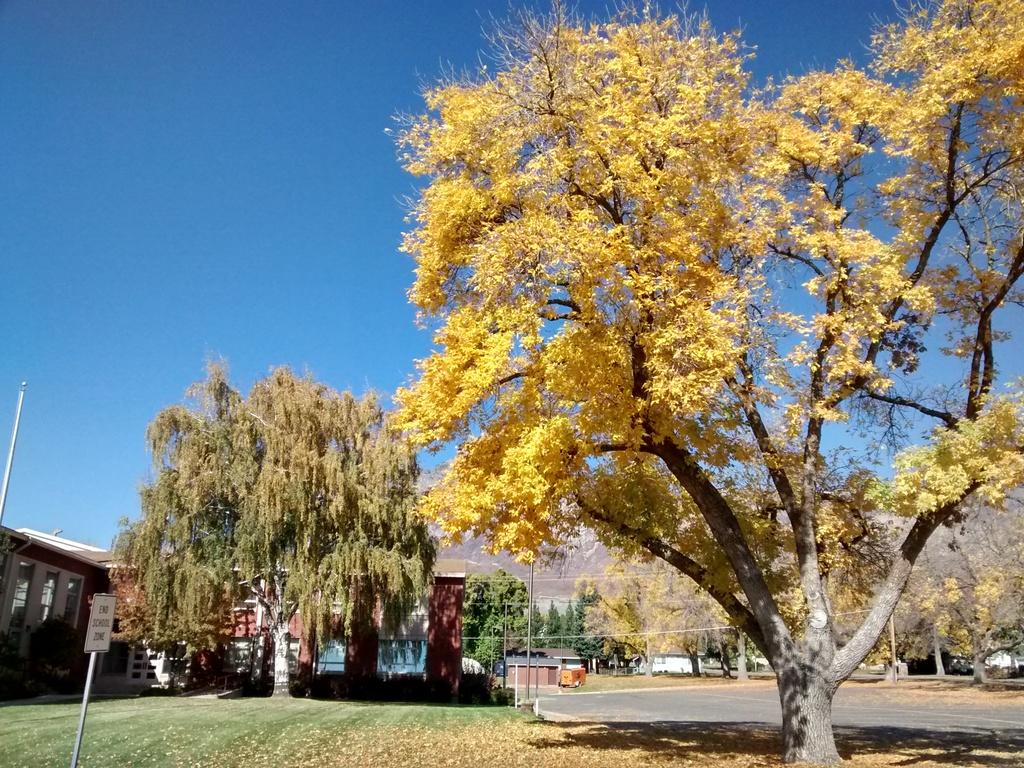What type of vegetation can be seen in the image? There are trees in the image. What else can be seen on the ground in the image? There is green grass in the image. What type of man-made structures are present in the image? There are houses in the image. What is visible in the sky in the image? The sky is clear in the image. What type of pathway is present in the image? There is a road in the image. What is the rate of the circle's rotation in the image? There is no circle present in the image, so it's not possible to determine its rate of rotation. 